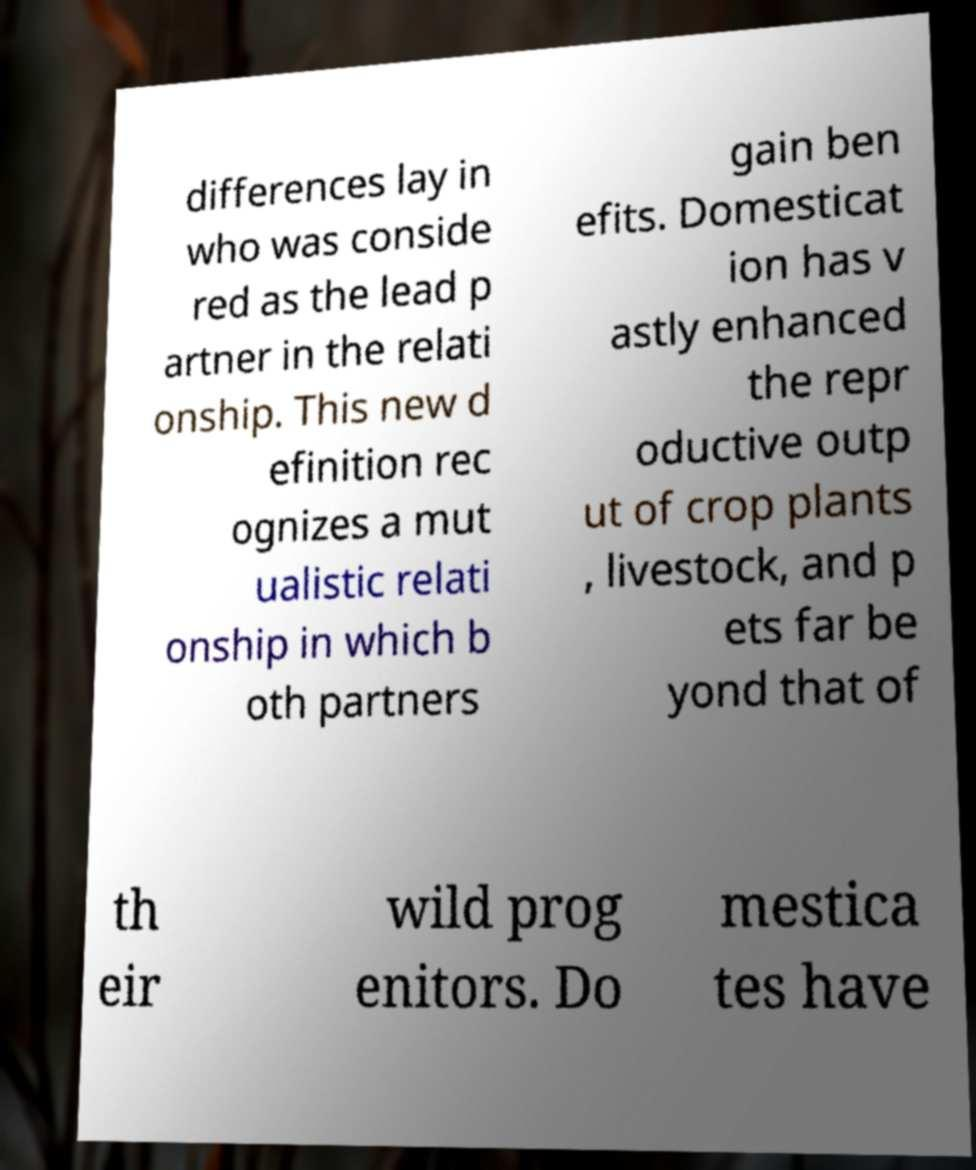Can you accurately transcribe the text from the provided image for me? differences lay in who was conside red as the lead p artner in the relati onship. This new d efinition rec ognizes a mut ualistic relati onship in which b oth partners gain ben efits. Domesticat ion has v astly enhanced the repr oductive outp ut of crop plants , livestock, and p ets far be yond that of th eir wild prog enitors. Do mestica tes have 